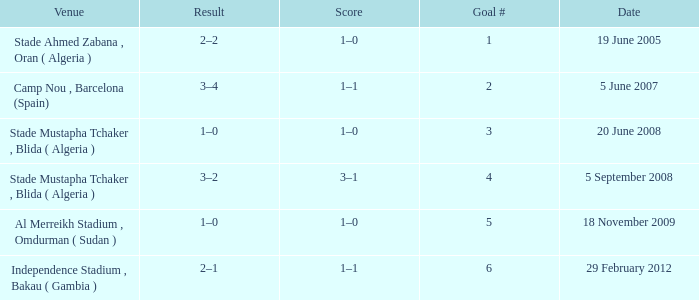What was the venue where goal #2 occured? Camp Nou , Barcelona (Spain). 